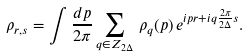Convert formula to latex. <formula><loc_0><loc_0><loc_500><loc_500>\rho _ { r , s } = \int \frac { d p } { 2 \pi } \sum _ { q \in Z _ { 2 \Delta } } \, \rho _ { q } ( p ) \, e ^ { i p r + i q \frac { 2 \pi } { 2 \Delta } s } .</formula> 